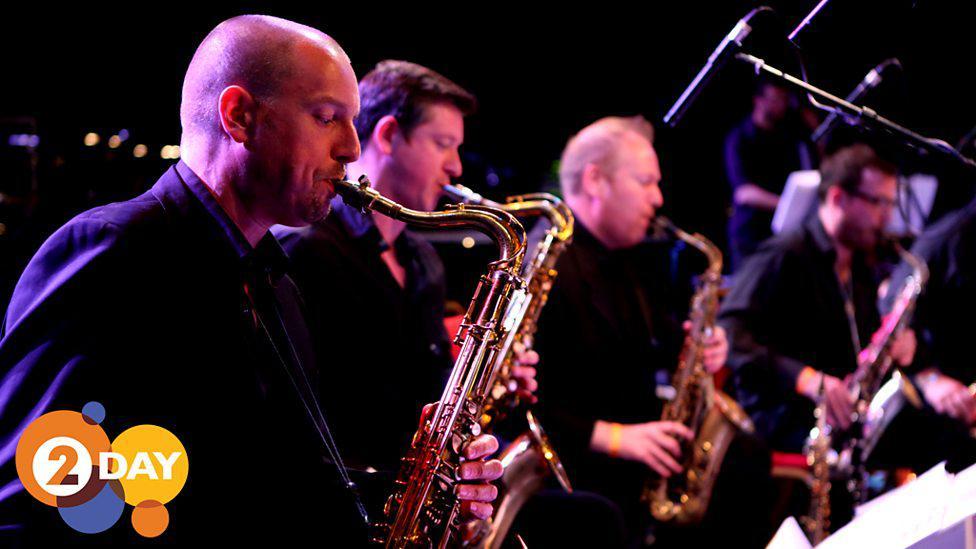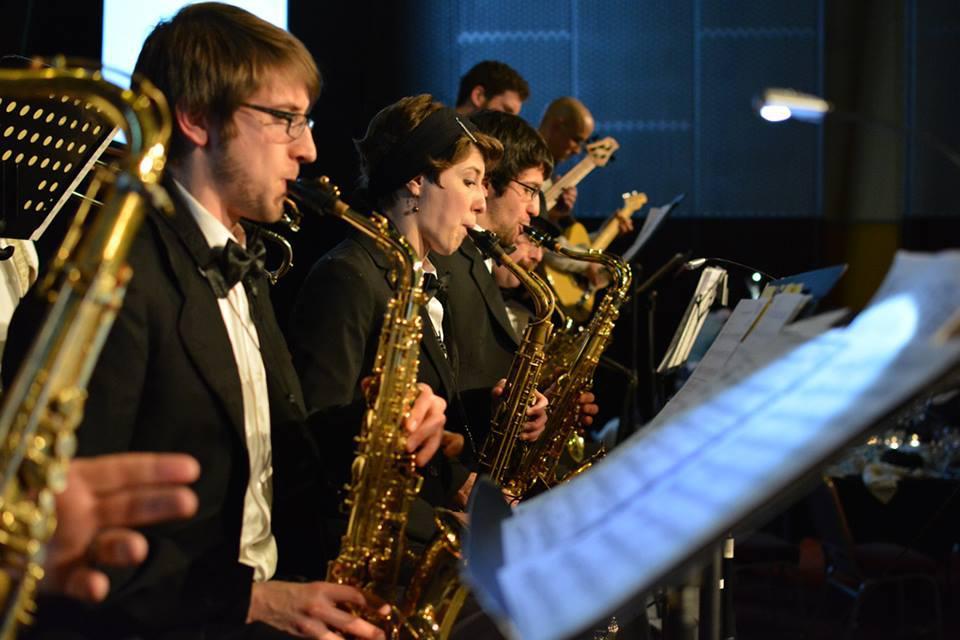The first image is the image on the left, the second image is the image on the right. Evaluate the accuracy of this statement regarding the images: "One of the musicians playing a saxophone depicted in the image on the right is a woman.". Is it true? Answer yes or no. Yes. The first image is the image on the left, the second image is the image on the right. Evaluate the accuracy of this statement regarding the images: "All of the saxophone players are facing rightward and standing in a single row.". Is it true? Answer yes or no. Yes. 